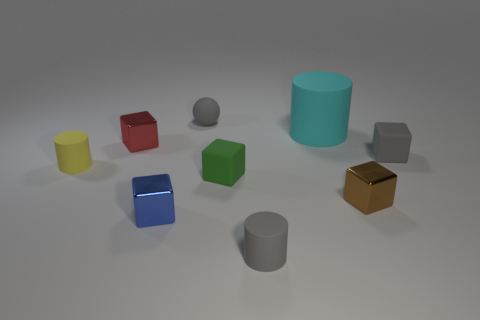Is the number of small rubber things greater than the number of large gray cubes?
Make the answer very short. Yes. How many objects are either tiny things to the right of the brown object or small matte cubes that are in front of the tiny gray rubber cube?
Offer a terse response. 2. There is a rubber cube that is the same size as the green rubber thing; what is its color?
Your response must be concise. Gray. Are the gray cube and the tiny gray ball made of the same material?
Your answer should be very brief. Yes. What is the cylinder that is in front of the tiny rubber cylinder that is on the left side of the gray matte sphere made of?
Give a very brief answer. Rubber. Are there more small gray rubber cylinders that are on the left side of the small yellow cylinder than blue metallic cylinders?
Offer a terse response. No. How many other things are there of the same size as the blue cube?
Give a very brief answer. 7. Do the ball and the big object have the same color?
Provide a succinct answer. No. There is a rubber cube to the right of the small rubber cube that is left of the big object that is to the left of the brown object; what is its color?
Offer a terse response. Gray. What number of small matte objects are on the right side of the small cylinder that is to the right of the gray matte object behind the gray matte cube?
Your answer should be compact. 1. 